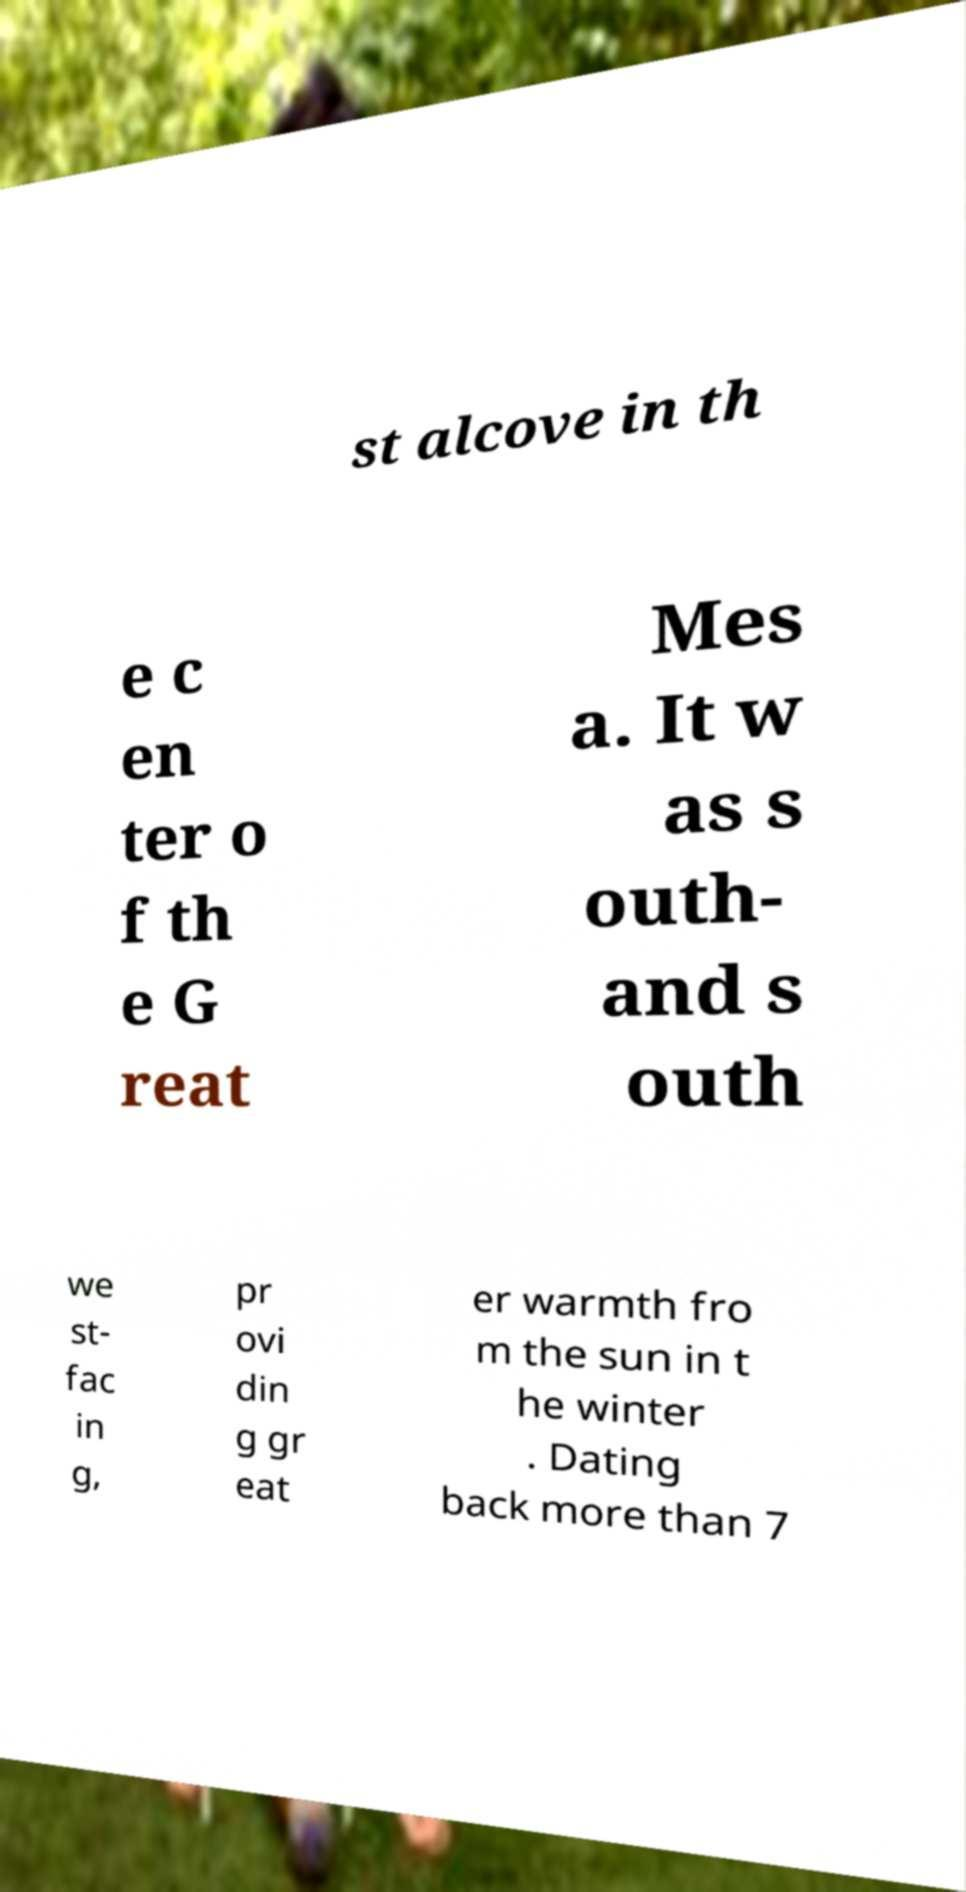Please identify and transcribe the text found in this image. st alcove in th e c en ter o f th e G reat Mes a. It w as s outh- and s outh we st- fac in g, pr ovi din g gr eat er warmth fro m the sun in t he winter . Dating back more than 7 